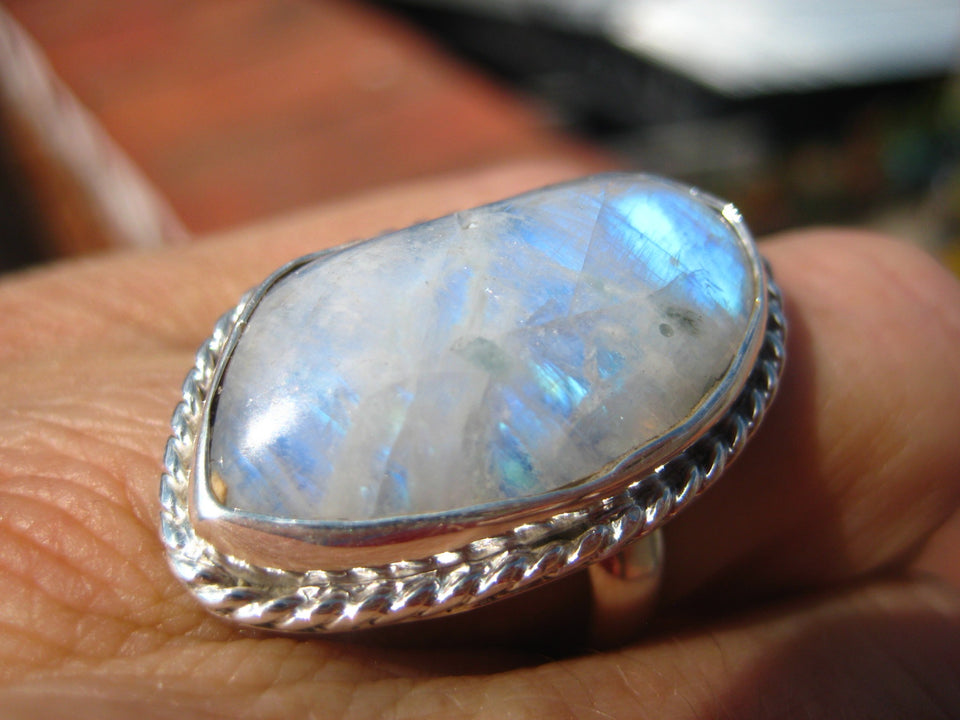What type of opal is this and how does its color variation affect its value? This gemstone appears to be a precious opal, characterized by its brilliant play-of-color. The variation in colors, including blues, greens, and flashes of orange, significantly enhances its value. Opals with a wide spectrum of colors are highly sought after in the gem market because they exhibit a captivating interplay of light. Can you explain the geological process that gives this opal its unique color patterns? Opals obtain their unique color patterns from the microscopic silica spheres within the stone. These spheres are arranged in a grid-like pattern, and as light passes through the spaces between them, it is diffracted, creating the characteristic play-of-color. The size and arrangement of these silica particles determine the color and intensity of the patterns. This process, occurring over millions of years, results in the beautiful and varied hues seen in high-quality opals like the one in the image. Imagine the ancient environment where this opal was formed. Describe it. Imagine a prehistoric landscape, millions of years ago, covered by shallow seas and rich with volcanic activity. Silica-rich water would have flowed through the crevices of the Earth's surface, depositing layers of silica within the spaces of decayed organic matter and rocks. Over vast periods, the slow evaporation of water left behind a delicate structure of silica spheres, eventually forming into the precious opal we see today. This ancient setting was a dance of earth and water, heat and cooling, creating the perfect conditions for one of nature’s most stunning gemstones. 